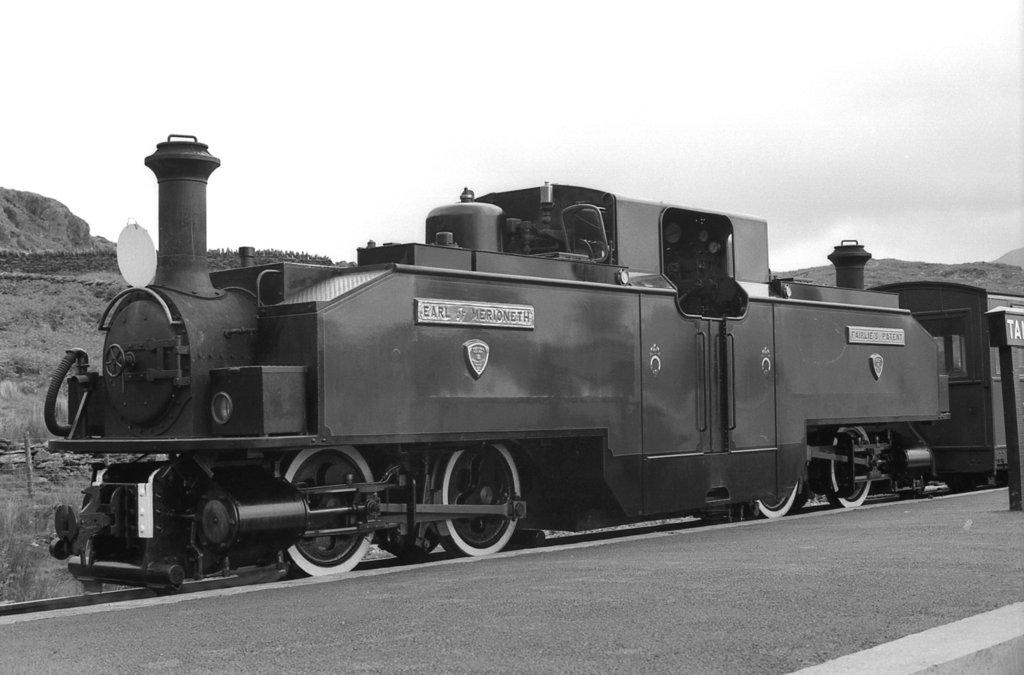What is the color scheme of the image? The image is black and white. What is the main subject of the image? There is a train moving on a track. What can be seen on the right side of the image? There is a platform on the right side. What type of natural features are visible in the background? Mountains, trees, and the sky are visible in the background. What architectural feature can be seen in the background? There is a railing visible in the background. What type of stone is being used to build the structure in the image? There is no structure being built in the image; it features a train moving on a track with a platform and natural and architectural features in the background. How does the train's movement affect the nerves of the passengers in the image? The image does not show the passengers or their nerves, so it cannot be determined how the train's movement affects them. 